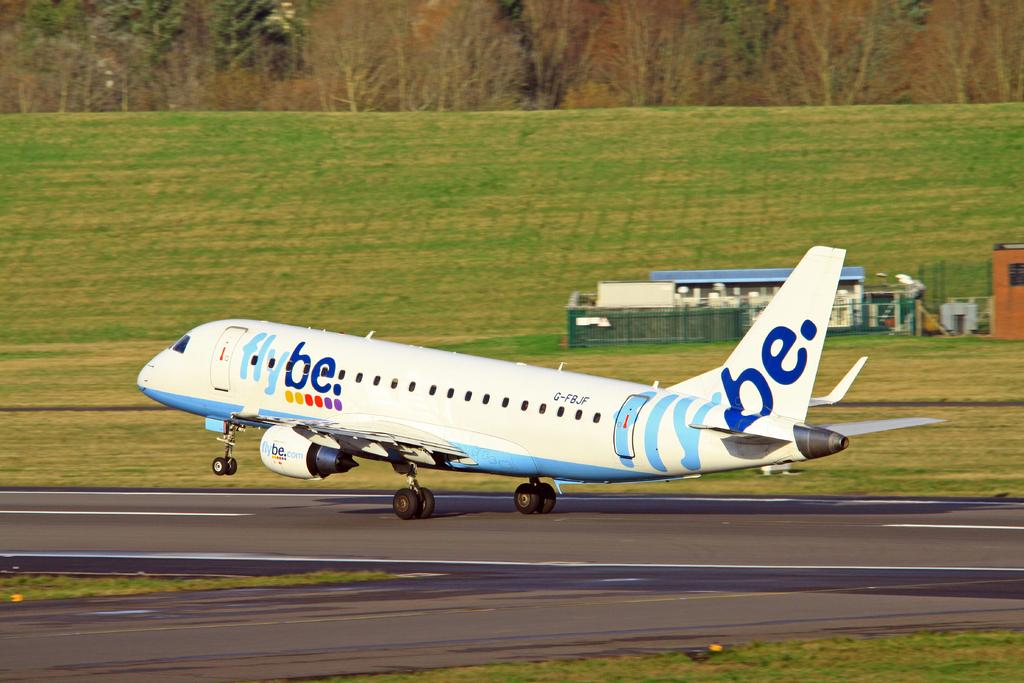Provide a one-sentence caption for the provided image. a white and blue plane with flybe written on it. 